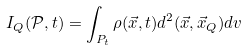Convert formula to latex. <formula><loc_0><loc_0><loc_500><loc_500>I _ { Q } ( \mathcal { P } , t ) = \int _ { P _ { t } } \rho ( \vec { x } , t ) d ^ { 2 } ( \vec { x } , \vec { x } _ { Q } ) d v</formula> 